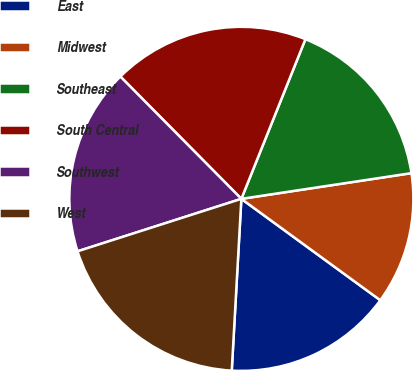Convert chart. <chart><loc_0><loc_0><loc_500><loc_500><pie_chart><fcel>East<fcel>Midwest<fcel>Southeast<fcel>South Central<fcel>Southwest<fcel>West<nl><fcel>15.86%<fcel>12.42%<fcel>16.54%<fcel>18.49%<fcel>17.52%<fcel>19.18%<nl></chart> 